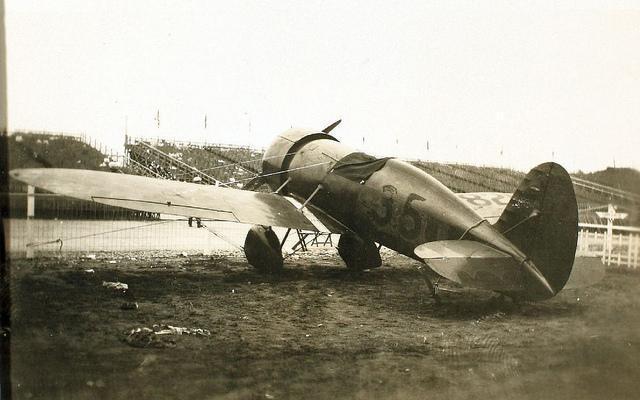How many giraffes are in the image?
Give a very brief answer. 0. 